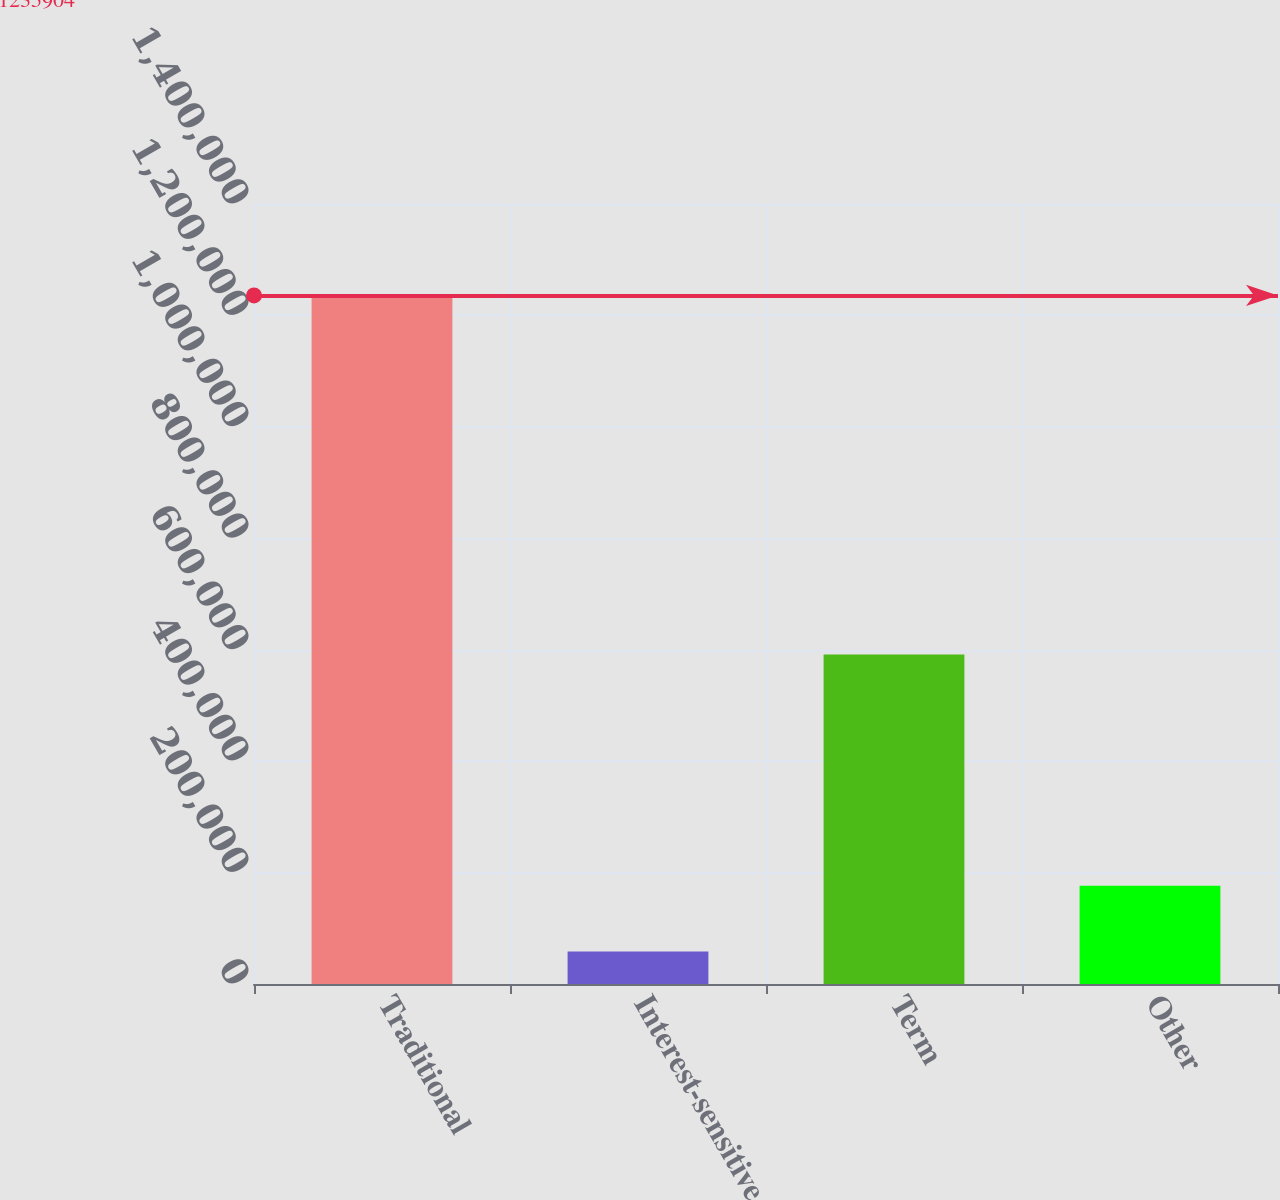<chart> <loc_0><loc_0><loc_500><loc_500><bar_chart><fcel>Traditional<fcel>Interest-sensitive<fcel>Term<fcel>Other<nl><fcel>1.2359e+06<fcel>58549<fcel>591628<fcel>176284<nl></chart> 